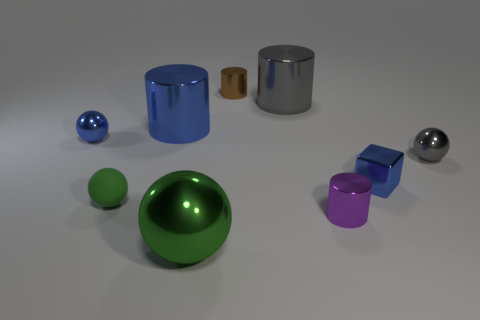Add 1 gray spheres. How many objects exist? 10 Subtract all spheres. How many objects are left? 5 Add 5 small gray objects. How many small gray objects exist? 6 Subtract 0 gray blocks. How many objects are left? 9 Subtract all cyan objects. Subtract all small green rubber balls. How many objects are left? 8 Add 1 small gray things. How many small gray things are left? 2 